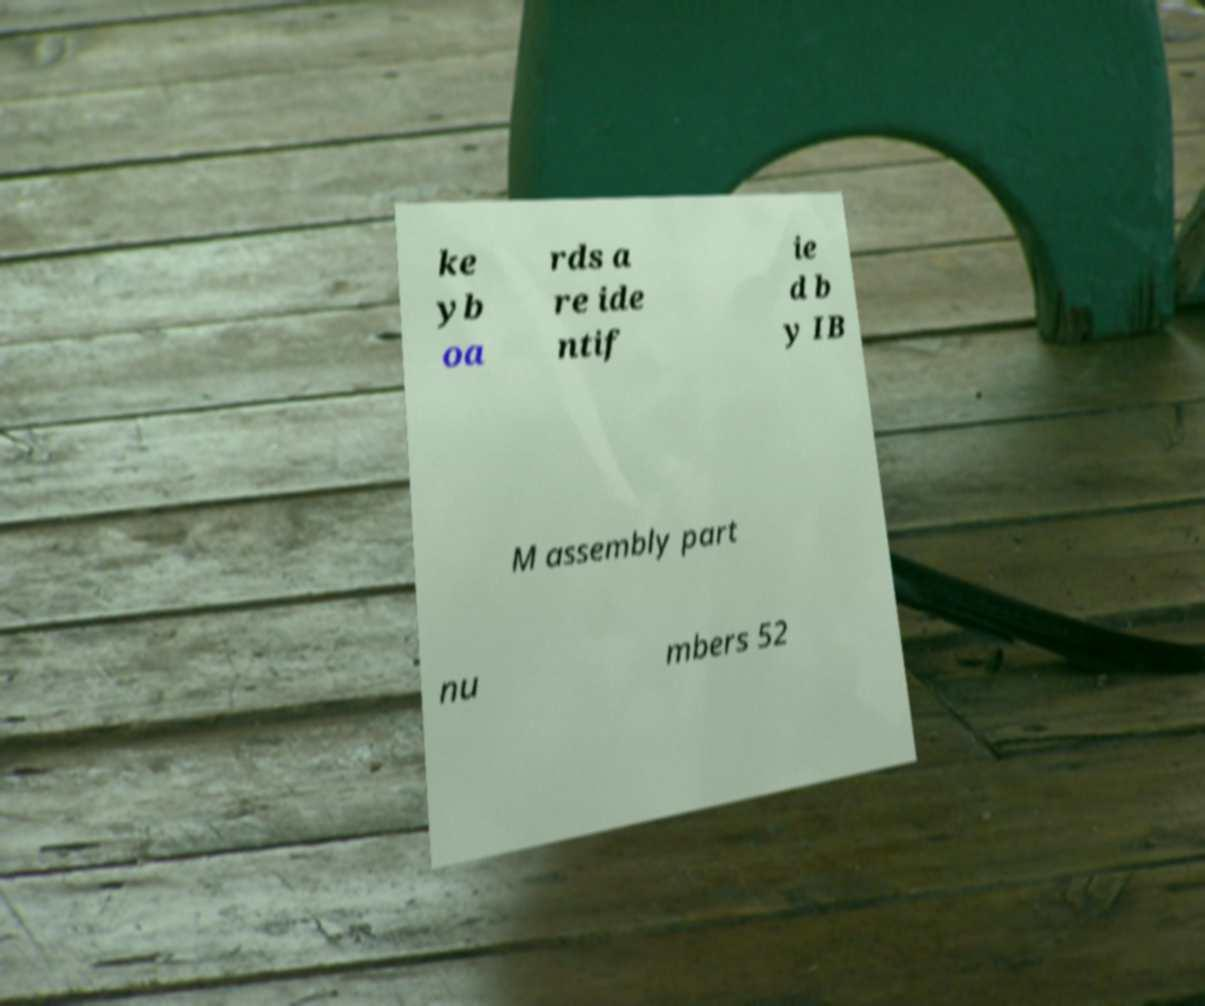What messages or text are displayed in this image? I need them in a readable, typed format. ke yb oa rds a re ide ntif ie d b y IB M assembly part nu mbers 52 